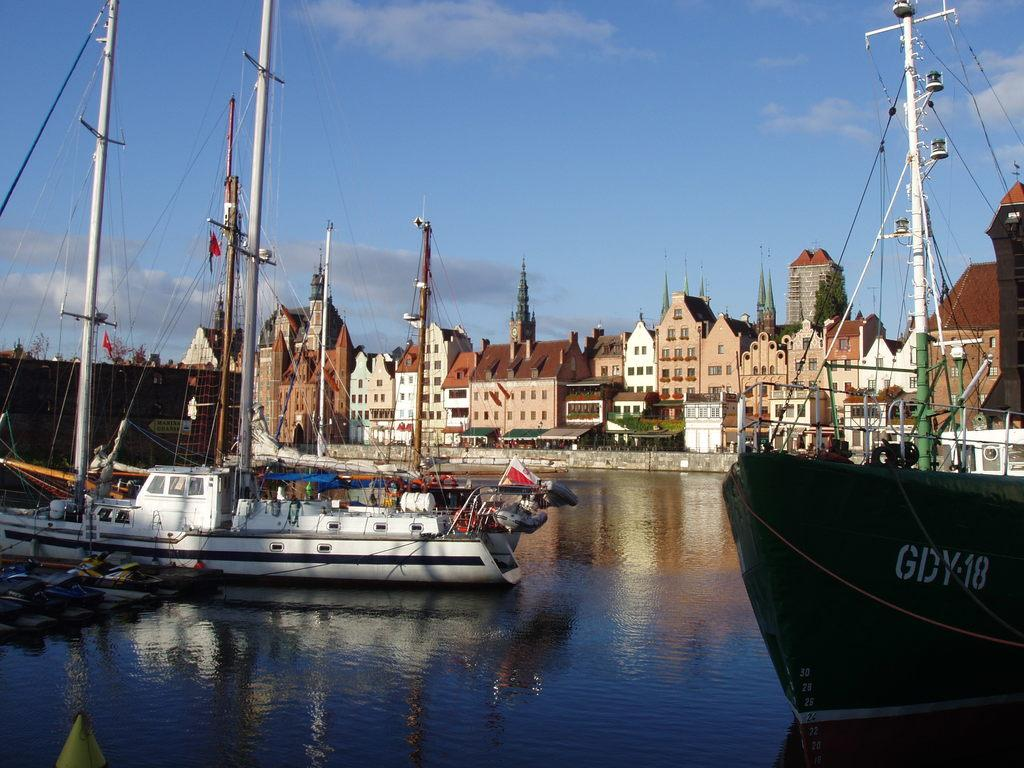What type of structures can be seen in the image? There are buildings with windows in the image. What is located in the water in the image? There are ships in the water in the image. What are the poles with wires used for in the image? The poles with wires are likely used for electrical or communication purposes in the image. What type of vegetation is present in the image? There are plants and trees in the image. What part of the natural environment is visible in the image? The sky is visible in the image, and clouds are present in the sky. What type of car is parked near the buildings in the image? There is no car present in the image; it features buildings, ships, poles with wires, plants, trees, and a sky with clouds. What is the value of the copper in the image? There is no copper present in the image, so it is not possible to determine its value. 